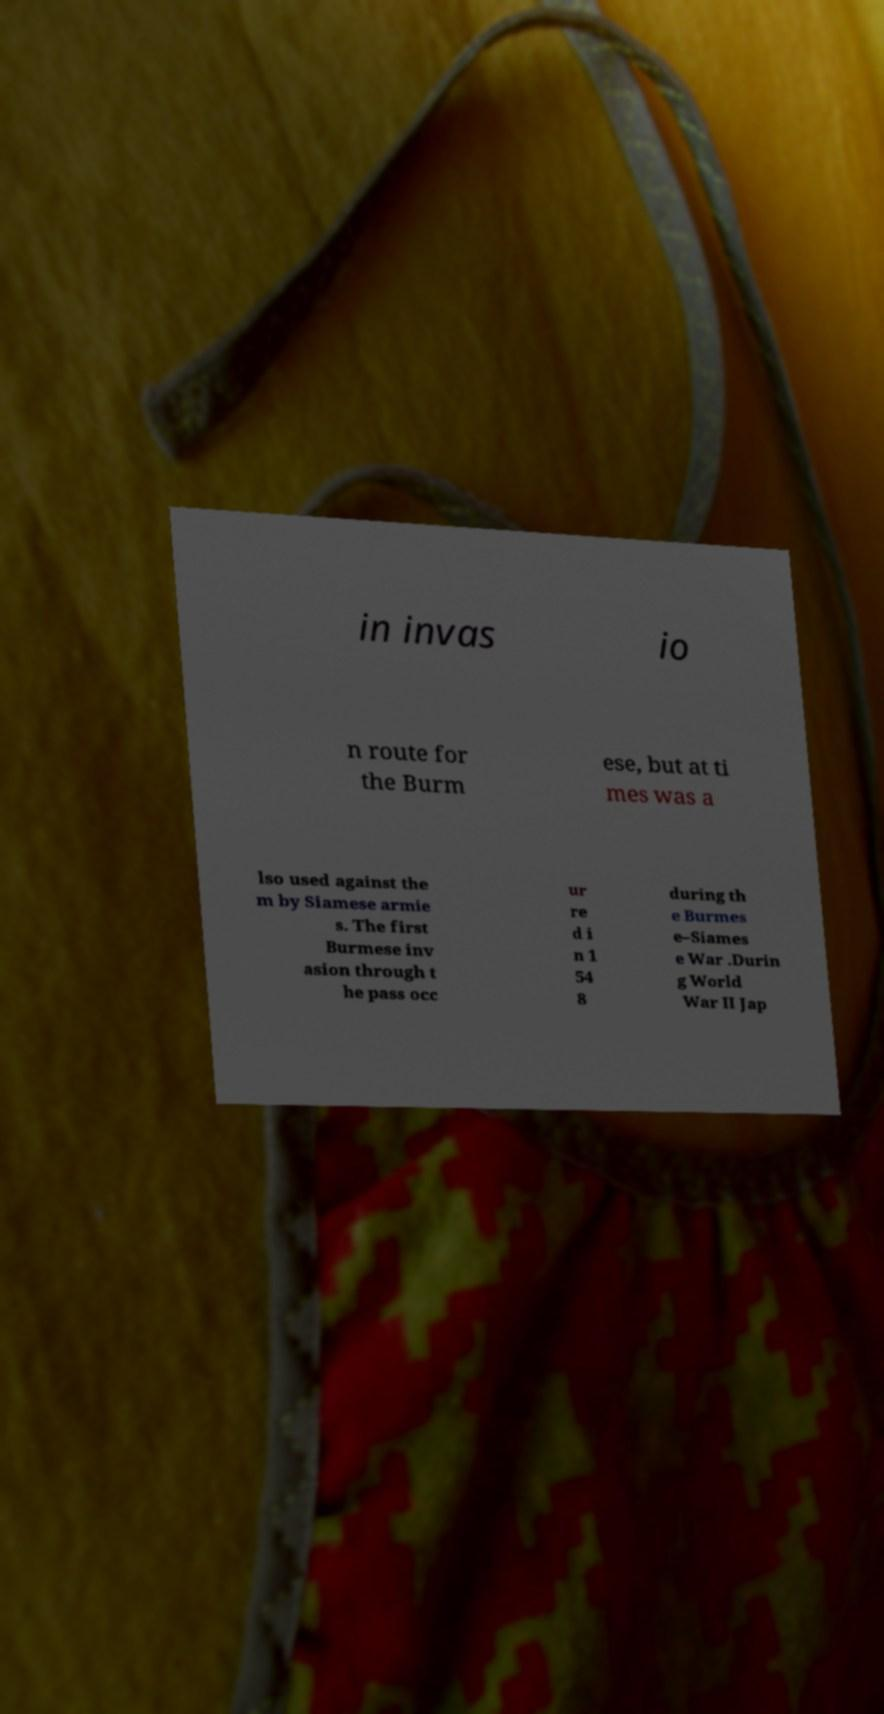Could you assist in decoding the text presented in this image and type it out clearly? in invas io n route for the Burm ese, but at ti mes was a lso used against the m by Siamese armie s. The first Burmese inv asion through t he pass occ ur re d i n 1 54 8 during th e Burmes e–Siames e War .Durin g World War II Jap 